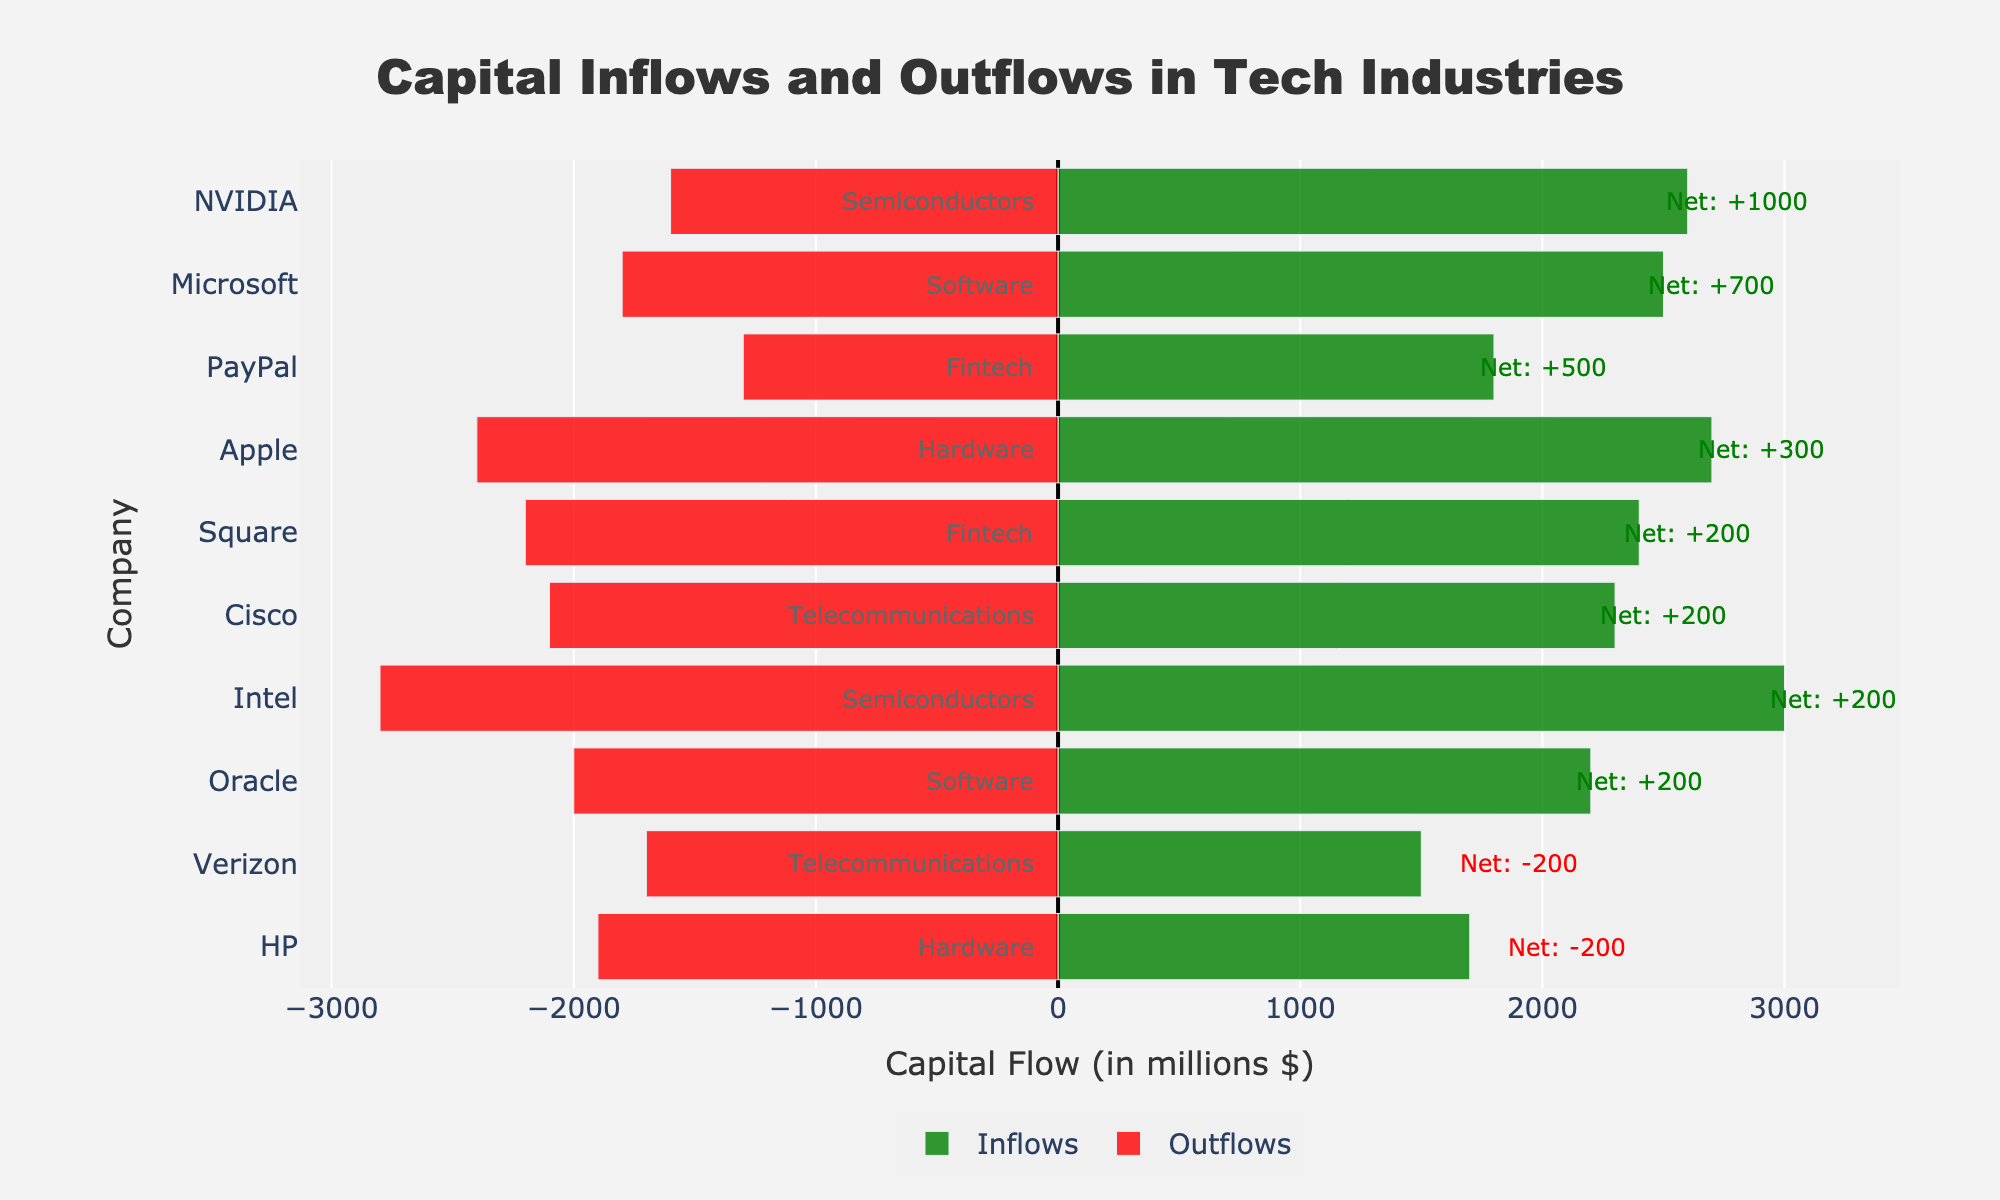Which company has the highest net inflow? The net inflow is calculated by subtracting the outflow from the inflow. By comparing the net flows of each company, NVIDIA has a net inflow of 1000 (2600 inflow - 1600 outflow), which is the highest among all companies listed.
Answer: NVIDIA Which sector has the highest combined inflow? To determine this, sum the inflows for each sector. For Software (Microsoft + Oracle): 2500 + 2200 = 4700; Hardware (Apple + HP): 2700 + 1700 = 4400; Semiconductors (Intel + NVIDIA): 3000 + 2600 = 5600; Telecommunications (Cisco + Verizon): 2300 + 1500 = 3800; Fintech (Square + PayPal): 2400 + 1800 = 4200. Semiconductors have the highest combined inflow at 5600.
Answer: Semiconductors What is the net flow for Apple and how does it compare to HP? Apple's net flow is calculated as 2700 inflow - 2400 outflow = 300. HP's net flow is 1700 inflow - 1900 outflow = -200. Comparing them, Apple's net flow (300) is higher than HP's net flow (-200).
Answer: Apple's net flow is higher What is the visual indicator for net negative flows and which companies have them? In the chart, net negative flows are indicated by an annotation in red color. The companies with net negative flows are HP (-200) and Verizon (-200).
Answer: HP and Verizon Compare the inflow difference between Microsoft and PayPal. Microsoft's inflow is 2500, and PayPal's inflow is 1800. The difference is calculated as 2500 - 1800 = 700.
Answer: 700 Which company has the closest inflow and outflow values? By comparing the inflow and outflow values visually, Oracle has an inflow of 2200 and an outflow of 2000, yielding a close difference of 200.
Answer: Oracle Identify the sector with the smallest total outflow. To determine this, sum the outflows for each sector. For Software (Microsoft + Oracle): 1800 + 2000 = 3800; Hardware (Apple + HP): 2400 + 1900 = 4300; Semiconductors (Intel + NVIDIA): 2800 + 1600 = 4400; Telecommunications (Cisco + Verizon): 2100 + 1700 = 3800; Fintech (Square + PayPal): 2200 + 1300 = 3500. Fintech has the smallest total outflow at 3500.
Answer: Fintech What are the net flows for companies within the Telecommunications sector? For Cisco, the net flow is 2300 inflow - 2100 outflow = 200. For Verizon, the net flow is 1500 inflow - 1700 outflow = -200.
Answer: Cisco: 200, Verizon: -200 Which sector has the largest disparity between its highest and lowest net flow values? Calculate the net flow for each sector and find the disparities. Software (Microsoft: 700, Oracle: 200) = 500; Hardware (Apple: 300, HP: -200) = 500; Semiconductors (Intel: 200, NVIDIA: 1000) = 800; Telecommunications (Cisco: 200, Verizon: -200) = 400; Fintech (Square: 200, PayPal: 500) = 300. Semiconductors have the largest disparity of 800.
Answer: Semiconductors What is the average net flow for the Software sector? Calculate the net flow for each company in the Software sector and compute the average. Microsoft: 700, Oracle: 200. Sum is 700 + 200 = 900 and there are 2 companies. Hence, the average net flow is 900 / 2 = 450.
Answer: 450 